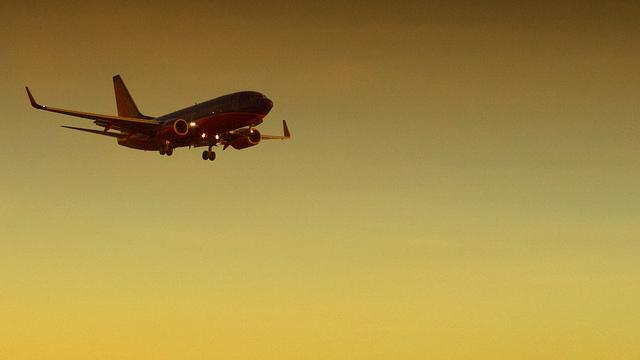What airlines is this?
Answer briefly. Southwest. Are there clouds in the photo?
Quick response, please. No. Is it dark?
Quick response, please. No. 